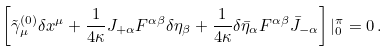<formula> <loc_0><loc_0><loc_500><loc_500>\left [ \tilde { \gamma } _ { \mu } ^ { ( 0 ) } \delta x ^ { \mu } + \frac { 1 } { 4 \kappa } J _ { + \alpha } F ^ { \alpha \beta } \delta \eta _ { \beta } + \frac { 1 } { 4 \kappa } \delta \bar { \eta } _ { \alpha } F ^ { \alpha \beta } \bar { J } _ { - \alpha } \right ] | _ { 0 } ^ { \pi } = 0 \, .</formula> 